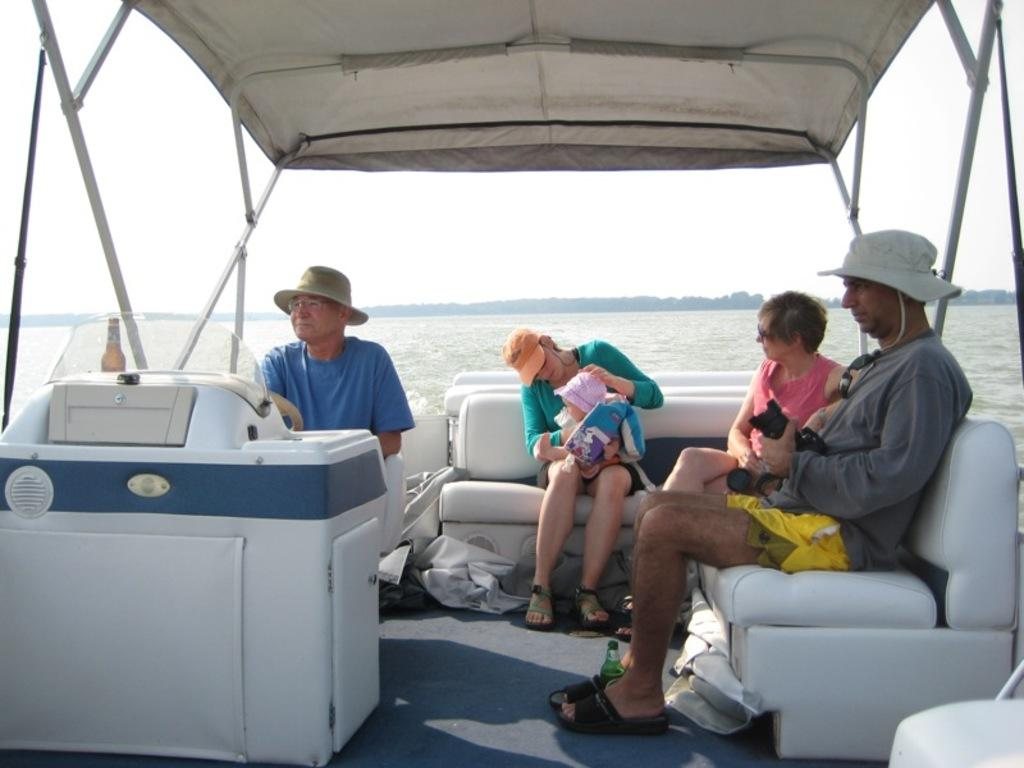What is the main subject of the picture? The main subject of the picture is a boat. What are the people in the boat doing? The people are sitting in the boat. What is the boat doing in the picture? The boat is sailing on the water. What can be seen in the background of the picture? The sky is clear in the background. What type of marble is being used to construct the boat in the image? There is no mention of marble being used to construct the boat in the image. The boat appears to be made of a different material, such as wood or metal. How many screws can be seen holding the boat together in the image? There is no mention of screws in the image. The boat's construction is not visible in the image, so it is impossible to determine how it is held together. 